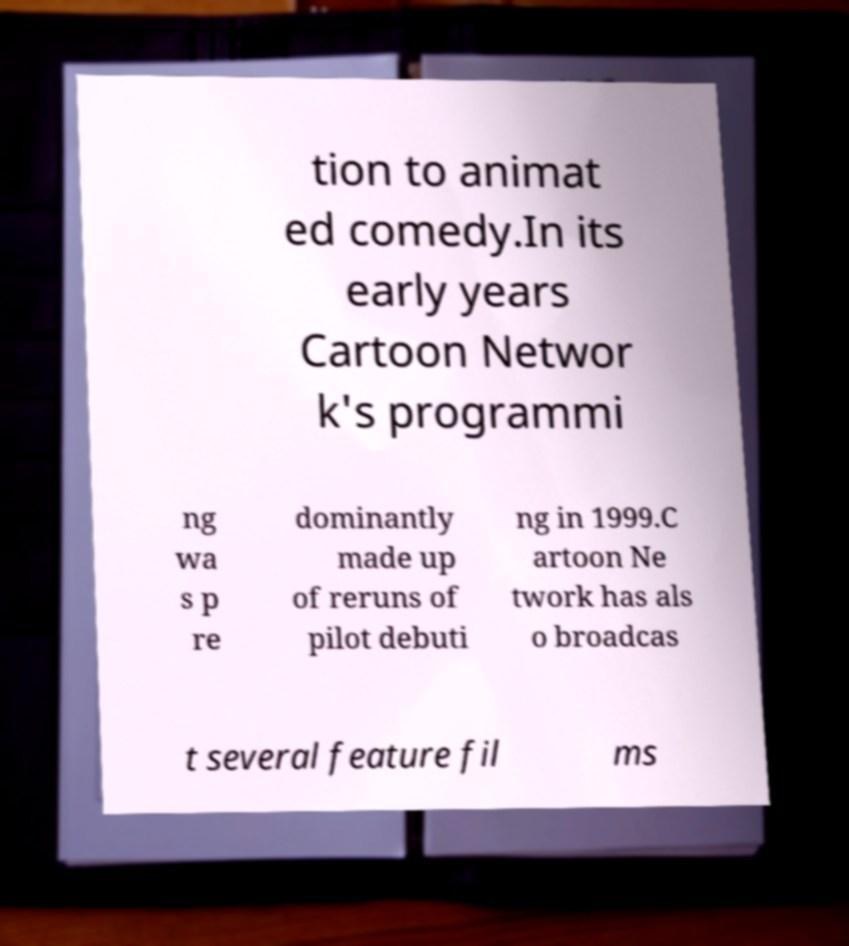Could you assist in decoding the text presented in this image and type it out clearly? tion to animat ed comedy.In its early years Cartoon Networ k's programmi ng wa s p re dominantly made up of reruns of pilot debuti ng in 1999.C artoon Ne twork has als o broadcas t several feature fil ms 